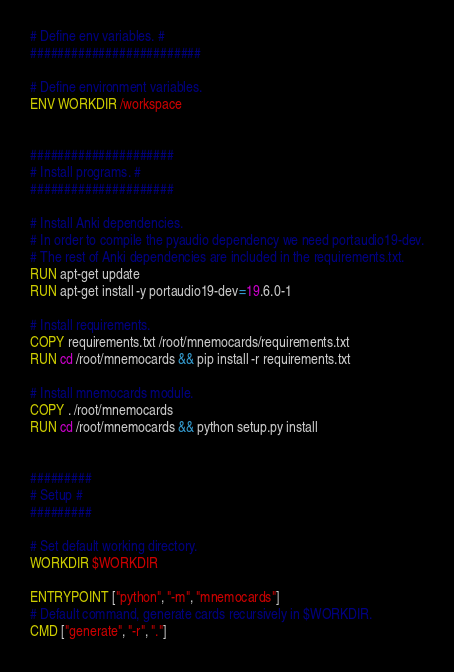<code> <loc_0><loc_0><loc_500><loc_500><_Dockerfile_># Define env variables. #
#########################

# Define environment variables.
ENV WORKDIR /workspace


#####################
# Install programs. #
#####################

# Install Anki dependencies.
# In order to compile the pyaudio dependency we need portaudio19-dev.
# The rest of Anki dependencies are included in the requirements.txt.
RUN apt-get update
RUN apt-get install -y portaudio19-dev=19.6.0-1

# Install requirements.
COPY requirements.txt /root/mnemocards/requirements.txt
RUN cd /root/mnemocards && pip install -r requirements.txt

# Install mnemocards module.
COPY . /root/mnemocards
RUN cd /root/mnemocards && python setup.py install


#########
# Setup #
#########

# Set default working directory.
WORKDIR $WORKDIR

ENTRYPOINT ["python", "-m", "mnemocards"]
# Default command, generate cards recursively in $WORKDIR.
CMD ["generate", "-r", "."]

</code> 